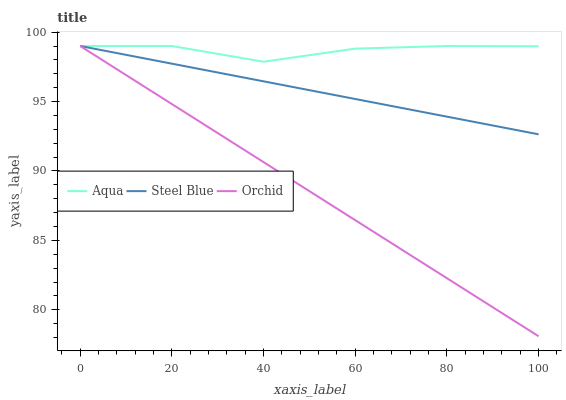Does Orchid have the minimum area under the curve?
Answer yes or no. Yes. Does Aqua have the maximum area under the curve?
Answer yes or no. Yes. Does Steel Blue have the minimum area under the curve?
Answer yes or no. No. Does Steel Blue have the maximum area under the curve?
Answer yes or no. No. Is Steel Blue the smoothest?
Answer yes or no. Yes. Is Aqua the roughest?
Answer yes or no. Yes. Is Orchid the smoothest?
Answer yes or no. No. Is Orchid the roughest?
Answer yes or no. No. Does Orchid have the lowest value?
Answer yes or no. Yes. Does Steel Blue have the lowest value?
Answer yes or no. No. Does Orchid have the highest value?
Answer yes or no. Yes. Does Orchid intersect Aqua?
Answer yes or no. Yes. Is Orchid less than Aqua?
Answer yes or no. No. Is Orchid greater than Aqua?
Answer yes or no. No. 